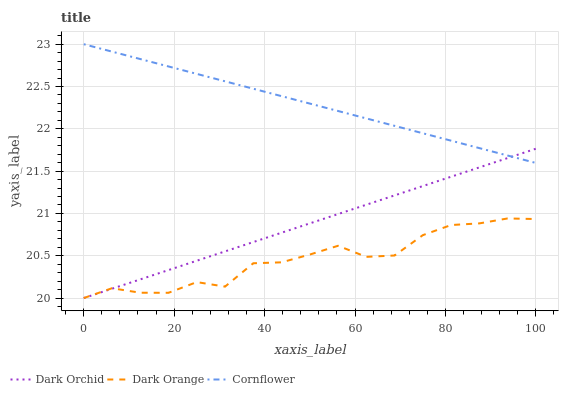Does Dark Orange have the minimum area under the curve?
Answer yes or no. Yes. Does Cornflower have the maximum area under the curve?
Answer yes or no. Yes. Does Dark Orchid have the minimum area under the curve?
Answer yes or no. No. Does Dark Orchid have the maximum area under the curve?
Answer yes or no. No. Is Cornflower the smoothest?
Answer yes or no. Yes. Is Dark Orange the roughest?
Answer yes or no. Yes. Is Dark Orchid the smoothest?
Answer yes or no. No. Is Dark Orchid the roughest?
Answer yes or no. No. Does Cornflower have the lowest value?
Answer yes or no. No. Does Dark Orchid have the highest value?
Answer yes or no. No. Is Dark Orange less than Cornflower?
Answer yes or no. Yes. Is Cornflower greater than Dark Orange?
Answer yes or no. Yes. Does Dark Orange intersect Cornflower?
Answer yes or no. No. 